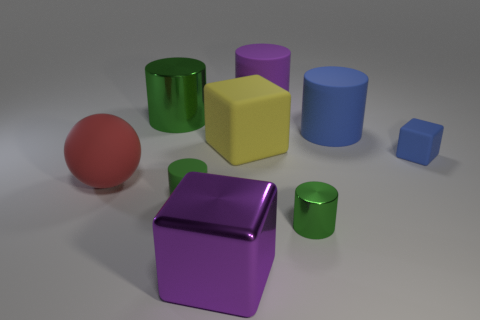Are there any other things that are the same shape as the red matte object?
Provide a succinct answer. No. What is the color of the big ball that is made of the same material as the tiny blue object?
Provide a short and direct response. Red. Is there a large purple object that has the same shape as the yellow object?
Offer a very short reply. Yes. Is the green cylinder behind the red sphere made of the same material as the small blue thing that is behind the tiny matte cylinder?
Ensure brevity in your answer.  No. What size is the green shiny cylinder left of the tiny rubber thing that is to the left of the thing that is on the right side of the big blue rubber object?
Ensure brevity in your answer.  Large. What material is the green cylinder that is the same size as the yellow object?
Your answer should be compact. Metal. Is there a blue cube of the same size as the purple metallic thing?
Offer a terse response. No. Is the red matte thing the same shape as the big green metal thing?
Ensure brevity in your answer.  No. Are there any tiny rubber objects that are on the right side of the rubber object that is in front of the large matte object in front of the small cube?
Your response must be concise. Yes. How many other objects are the same color as the metal block?
Your answer should be compact. 1. 